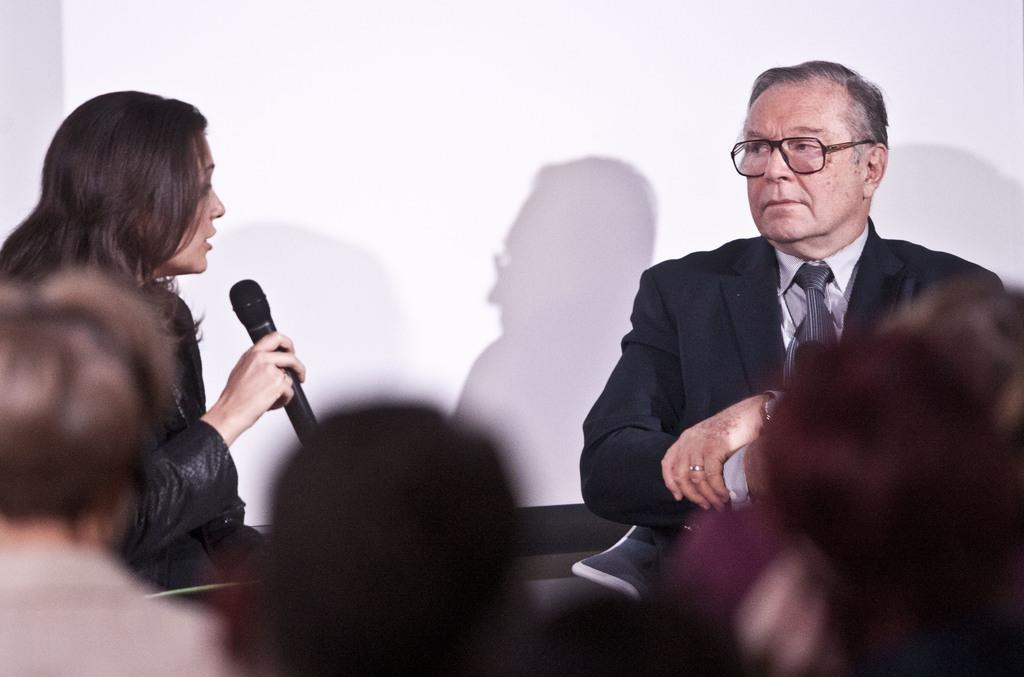What is happening in the image? There are people sitting in the image, and two people are opposite them. Can you describe the two people opposite the sitting people? One of them is a man wearing a black suit, and the other person is a lady holding a microphone. How does the bear help the man in the black suit in the image? There is no bear present in the image, so it cannot help the man in the black suit. 